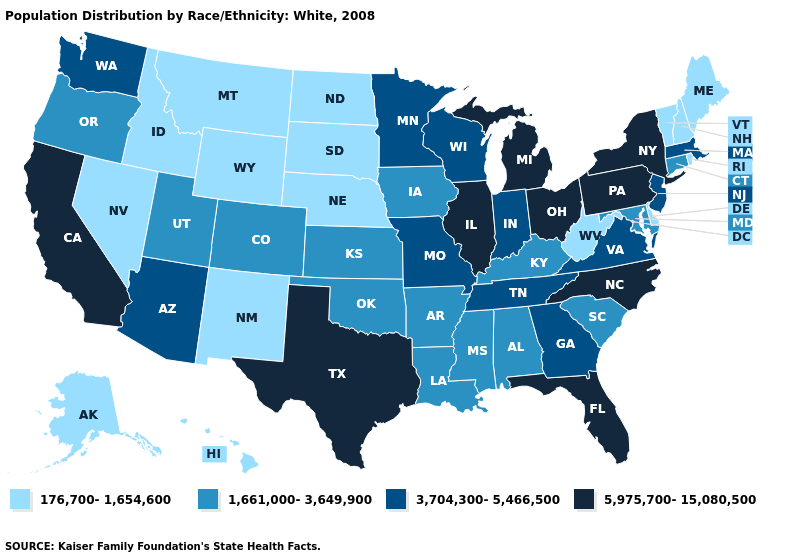What is the lowest value in the Northeast?
Short answer required. 176,700-1,654,600. Is the legend a continuous bar?
Answer briefly. No. Does the first symbol in the legend represent the smallest category?
Short answer required. Yes. Does the map have missing data?
Keep it brief. No. Does the first symbol in the legend represent the smallest category?
Be succinct. Yes. Does Arkansas have the lowest value in the USA?
Be succinct. No. What is the value of Oklahoma?
Write a very short answer. 1,661,000-3,649,900. What is the lowest value in the USA?
Short answer required. 176,700-1,654,600. Among the states that border Vermont , which have the highest value?
Be succinct. New York. Name the states that have a value in the range 5,975,700-15,080,500?
Keep it brief. California, Florida, Illinois, Michigan, New York, North Carolina, Ohio, Pennsylvania, Texas. What is the value of Montana?
Be succinct. 176,700-1,654,600. Name the states that have a value in the range 5,975,700-15,080,500?
Concise answer only. California, Florida, Illinois, Michigan, New York, North Carolina, Ohio, Pennsylvania, Texas. Does Idaho have the lowest value in the USA?
Quick response, please. Yes. Does Delaware have the lowest value in the South?
Short answer required. Yes. What is the value of Missouri?
Concise answer only. 3,704,300-5,466,500. 